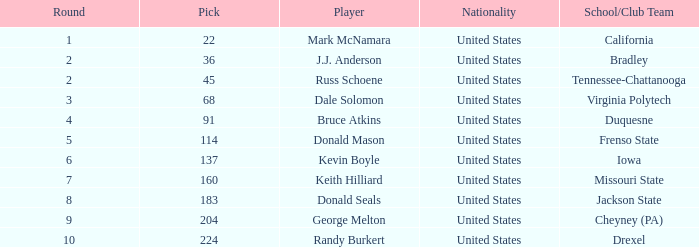In what earliest stage did donald mason possess a pick exceeding 114? None. 